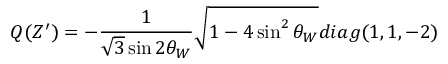<formula> <loc_0><loc_0><loc_500><loc_500>Q ( Z ^ { \prime } ) = - \frac { 1 } { \sqrt { 3 } \sin 2 \theta _ { W } } \sqrt { 1 - 4 \sin ^ { 2 } \theta _ { W } } d i a g ( 1 , 1 , - 2 )</formula> 